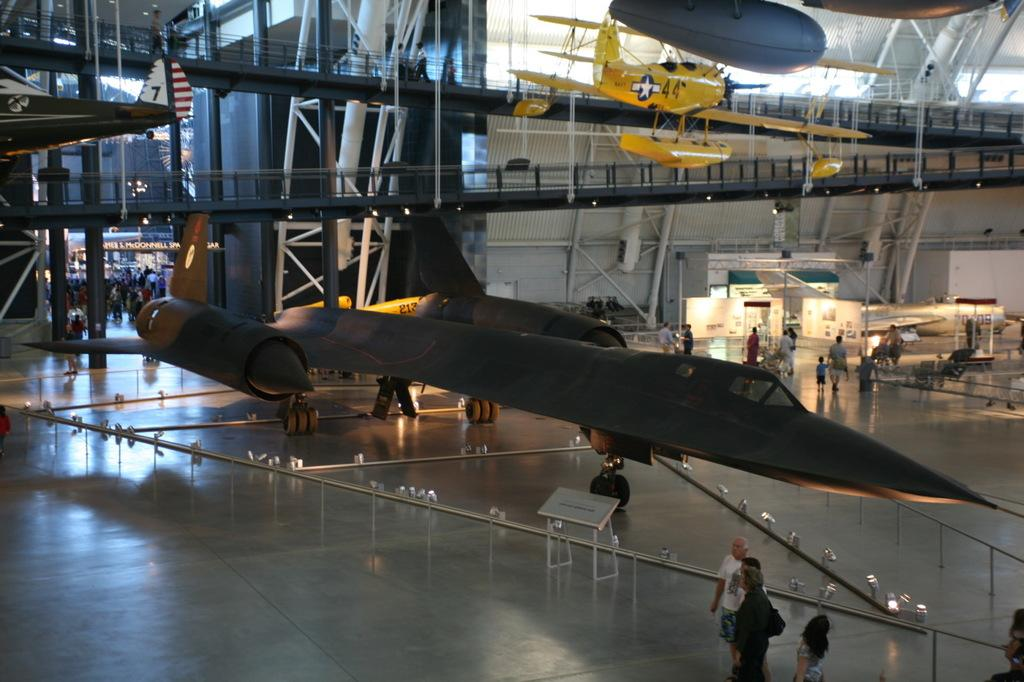What is the main subject of the image? The main subject of the image is an airplane on the ground. What else can be seen in the image besides the airplane? There is a group of people walking in the image. What can be seen in the background of the image? There are rods visible in the background of the image. What type of scissors are being used by the laborer at the party in the image? There is no laborer or party present in the image, and therefore no scissors can be observed. 